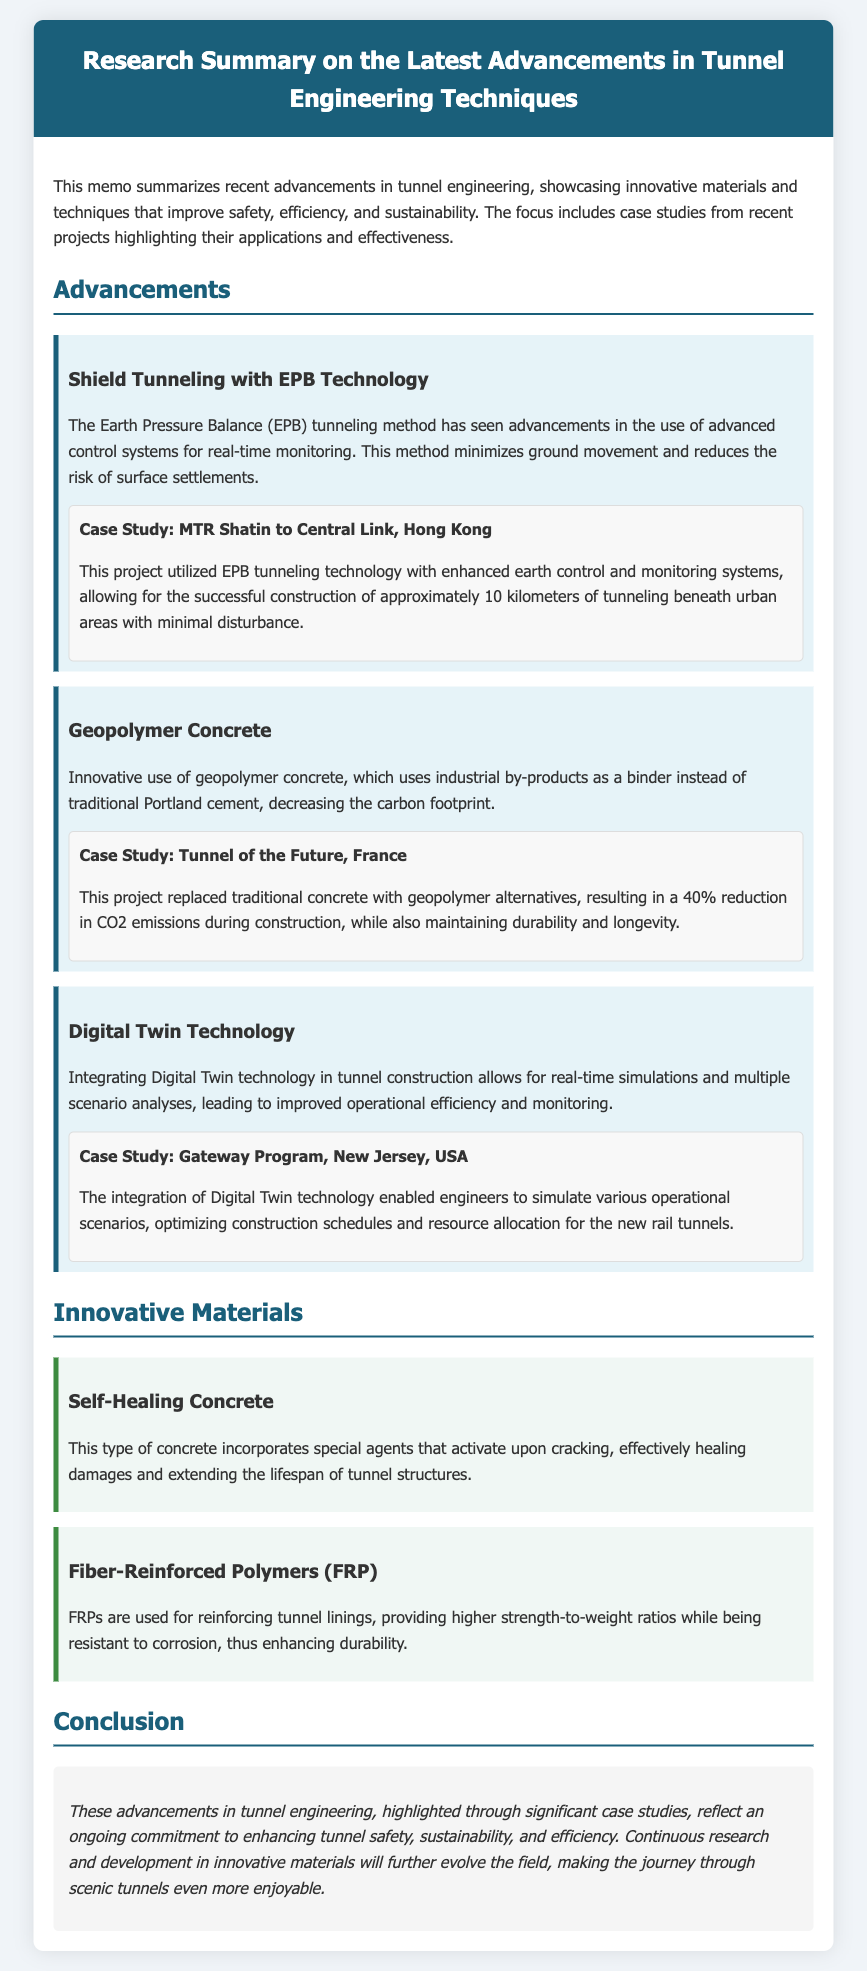What tunneling method utilizes advanced control systems for monitoring? The document mentions that the Earth Pressure Balance (EPB) tunneling method has seen advancements in the use of advanced control systems for real-time monitoring.
Answer: EPB Tunneling Which case study involved the MTR Shatin to Central Link? The document provides a case study for the MTR Shatin to Central Link, which utilized EPB tunneling technology.
Answer: MTR Shatin to Central Link What percentage reduction in CO2 emissions was achieved using geopolymer concrete in the Tunnel of the Future? The document states that the project resulted in a 40% reduction in CO2 emissions during construction by replacing traditional concrete with geopolymer alternatives.
Answer: 40% What type of concrete incorporates special agents for self-healing? The document describes a type of concrete that incorporates special agents that activate upon cracking, referred to as self-healing concrete.
Answer: Self-Healing Concrete Which technology allows for real-time simulations in tunnel construction? The document discusses the integration of Digital Twin technology, which enables real-time simulations and scenario analyses in tunnel construction.
Answer: Digital Twin Technology What is one benefit of using Fiber-Reinforced Polymers (FRP) in tunnel linings? The document explains that FRPs provide higher strength-to-weight ratios while being resistant to corrosion, enhancing durability.
Answer: Higher strength-to-weight ratios What key focus areas does the memo summarize regarding tunnel engineering? The document indicates that the focus includes advancements in safety, efficiency, and sustainability in tunnel engineering.
Answer: Safety, efficiency, sustainability What does the conclusion suggest about ongoing research in tunnel engineering? The conclusion highlights the ongoing commitment to enhancing tunnel safety, sustainability, and efficiency through continuous research and innovative materials.
Answer: Ongoing commitment Which case study used Digital Twin technology for optimizing construction schedules? The document mentions that the Gateway Program in New Jersey, USA, was a case study where Digital Twin technology was integrated to optimize construction schedules.
Answer: Gateway Program 